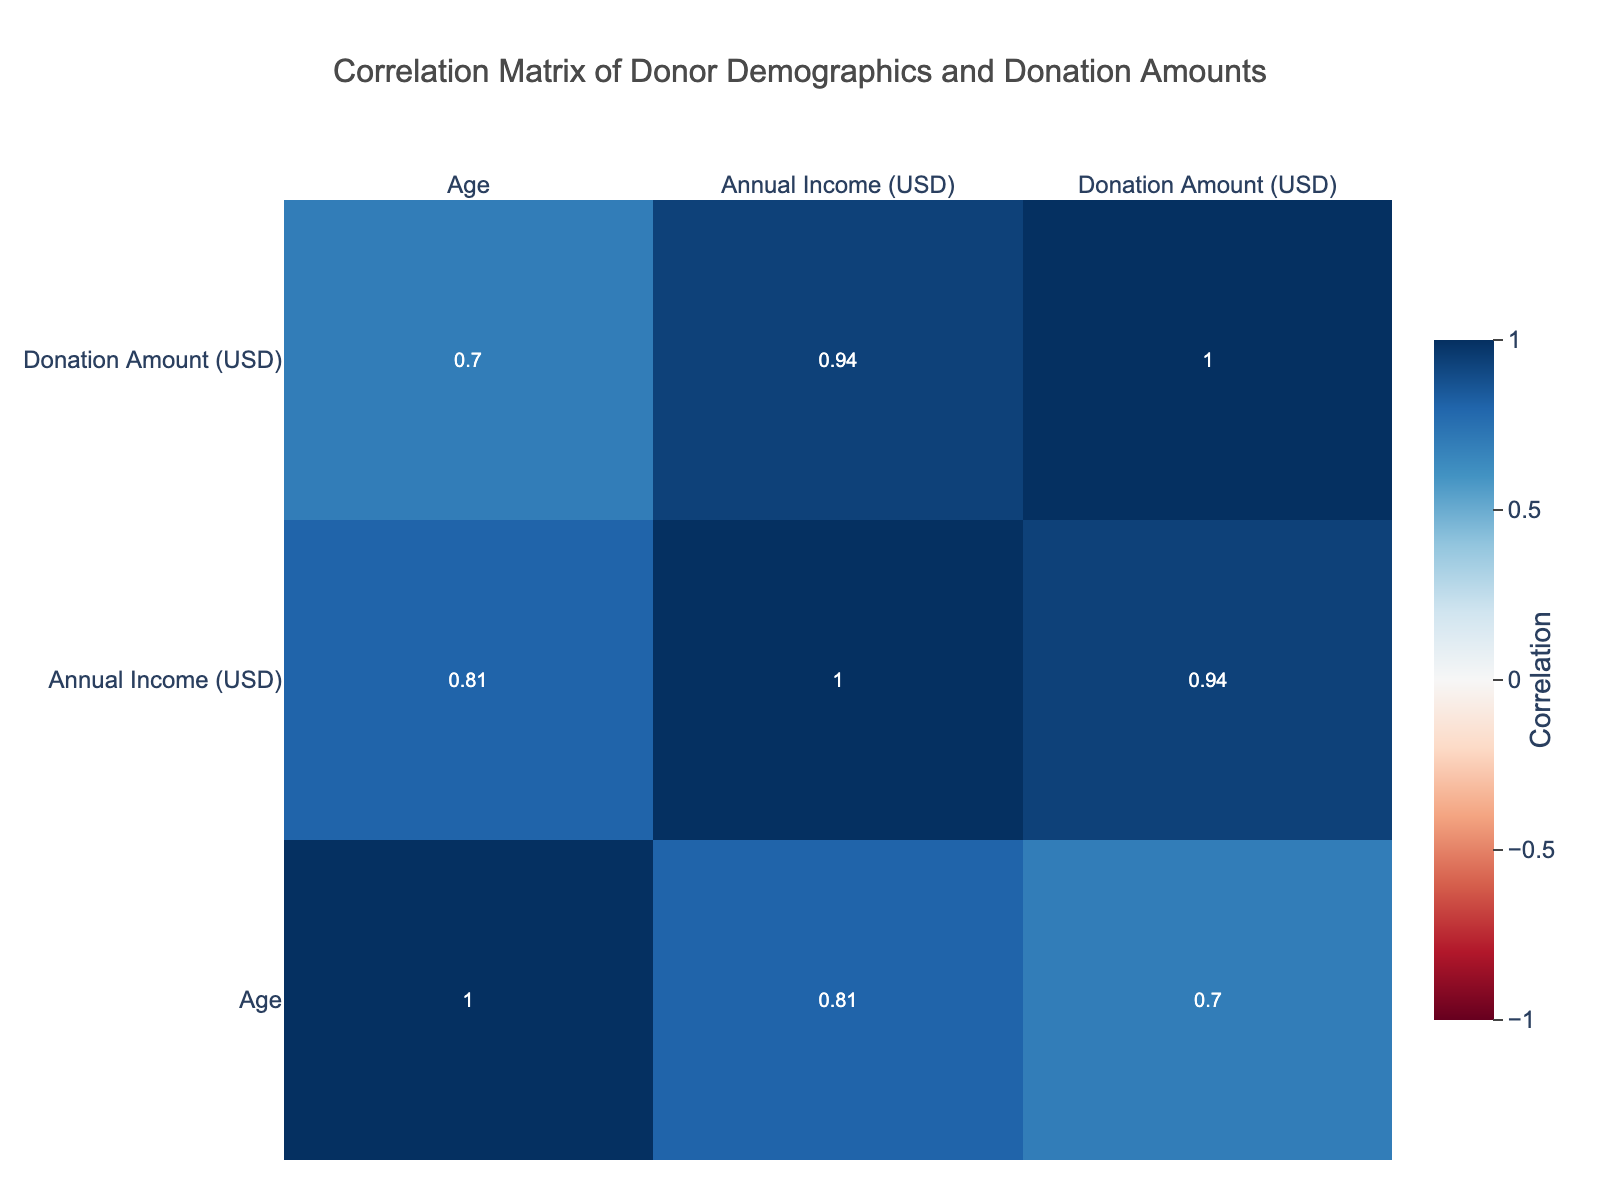What is the correlation between age and donation amount? From the correlation table, we identify the value at the intersection of 'Age' and 'Donation Amount'. In this case, the correlation value is 0.71, which indicates a strong positive correlation. This suggests that as age increases, donation amounts tend to also increase.
Answer: 0.71 Is there a correlation between education level and donation amount? The correlation table shows a value of 0.57 between 'Education Level' and 'Donation Amount', indicating a moderate positive correlation. This suggests that higher education levels are associated with higher donation amounts.
Answer: 0.57 What is the average donation amount for donors who have a Master's degree? We filter the data for individuals with a 'Master's' education, which shows two relevant cases: one donating 500 and another donating 1200. Adding these values gives 1700, and dividing by the number of cases (2) provides an average of 850.
Answer: 850 Is it true that older donors tend to donate more? By examining the correlation between 'Age' and 'Donation Amount', we observe a positive correlation value of 0.71. This supports the idea that older donors generally contribute larger amounts. Thus, the statement is true.
Answer: Yes What is the correlation between annual income and donation amount? Looking at the correlation table, the value at the intersection of 'Annual Income' and 'Donation Amount' is 0.88. This indicates a very strong positive correlation, meaning those with higher annual incomes are likely to donate larger amounts.
Answer: 0.88 How does location affect the donation amount, based on the correlation values? While the correlation table does not provide a direct correlation for 'Location', it shows that related factors like age, income, and education, which are influenced by location, have high correlation values with donation amounts. This implies that location indirectly affects donation behavior, but for precise correlation, more granular data would be needed. Thus, a direct correlation cannot be specified with the provided data.
Answer: Not specified Which occupation has the highest average donation amount? Calculating the average donation for each occupation, we find the 'Financial Analyst' has a donation of 1200, while others have lower amounts. Therefore, among the listed occupations, this one has the highest average donation amount.
Answer: Financial Analyst Is there any occupation where the donation amount is notably on the lower side? Referring to the table, the lowest donation amount is 150 made by 'Social Worker'. Hence, this occupation shows a notably lower donation compared to others. Thus, the answer is yes.
Answer: Yes What would be the average donation from all donors living in an urban location? We identify donors from 'Urban' locations and find their donations: 200, 1000, 1200, totaling to 2400. There are four cases, so the average donation is 2400/4 = 600.
Answer: 600 